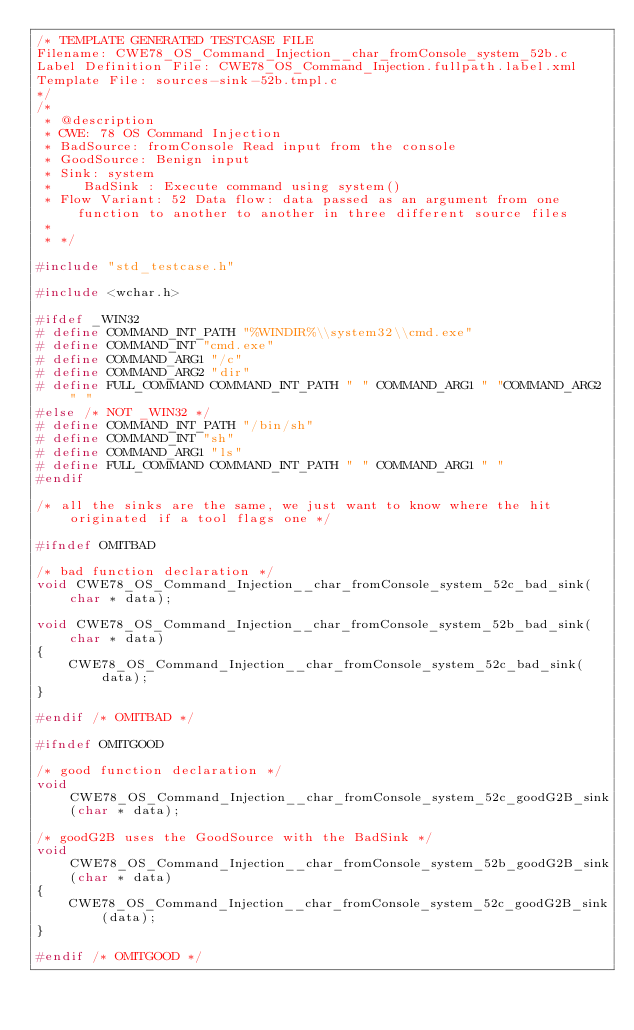Convert code to text. <code><loc_0><loc_0><loc_500><loc_500><_C_>/* TEMPLATE GENERATED TESTCASE FILE
Filename: CWE78_OS_Command_Injection__char_fromConsole_system_52b.c
Label Definition File: CWE78_OS_Command_Injection.fullpath.label.xml
Template File: sources-sink-52b.tmpl.c
*/
/*
 * @description
 * CWE: 78 OS Command Injection
 * BadSource: fromConsole Read input from the console
 * GoodSource: Benign input
 * Sink: system
 *    BadSink : Execute command using system()
 * Flow Variant: 52 Data flow: data passed as an argument from one function to another to another in three different source files
 *
 * */

#include "std_testcase.h"

#include <wchar.h>

#ifdef _WIN32
# define COMMAND_INT_PATH "%WINDIR%\\system32\\cmd.exe"
# define COMMAND_INT "cmd.exe"
# define COMMAND_ARG1 "/c"
# define COMMAND_ARG2 "dir"
# define FULL_COMMAND COMMAND_INT_PATH " " COMMAND_ARG1 " "COMMAND_ARG2 " "
#else /* NOT _WIN32 */
# define COMMAND_INT_PATH "/bin/sh"
# define COMMAND_INT "sh"
# define COMMAND_ARG1 "ls"
# define FULL_COMMAND COMMAND_INT_PATH " " COMMAND_ARG1 " "
#endif

/* all the sinks are the same, we just want to know where the hit originated if a tool flags one */

#ifndef OMITBAD

/* bad function declaration */
void CWE78_OS_Command_Injection__char_fromConsole_system_52c_bad_sink(char * data);

void CWE78_OS_Command_Injection__char_fromConsole_system_52b_bad_sink(char * data)
{
    CWE78_OS_Command_Injection__char_fromConsole_system_52c_bad_sink(data);
}

#endif /* OMITBAD */

#ifndef OMITGOOD

/* good function declaration */
void CWE78_OS_Command_Injection__char_fromConsole_system_52c_goodG2B_sink(char * data);

/* goodG2B uses the GoodSource with the BadSink */
void CWE78_OS_Command_Injection__char_fromConsole_system_52b_goodG2B_sink(char * data)
{
    CWE78_OS_Command_Injection__char_fromConsole_system_52c_goodG2B_sink(data);
}

#endif /* OMITGOOD */
</code> 